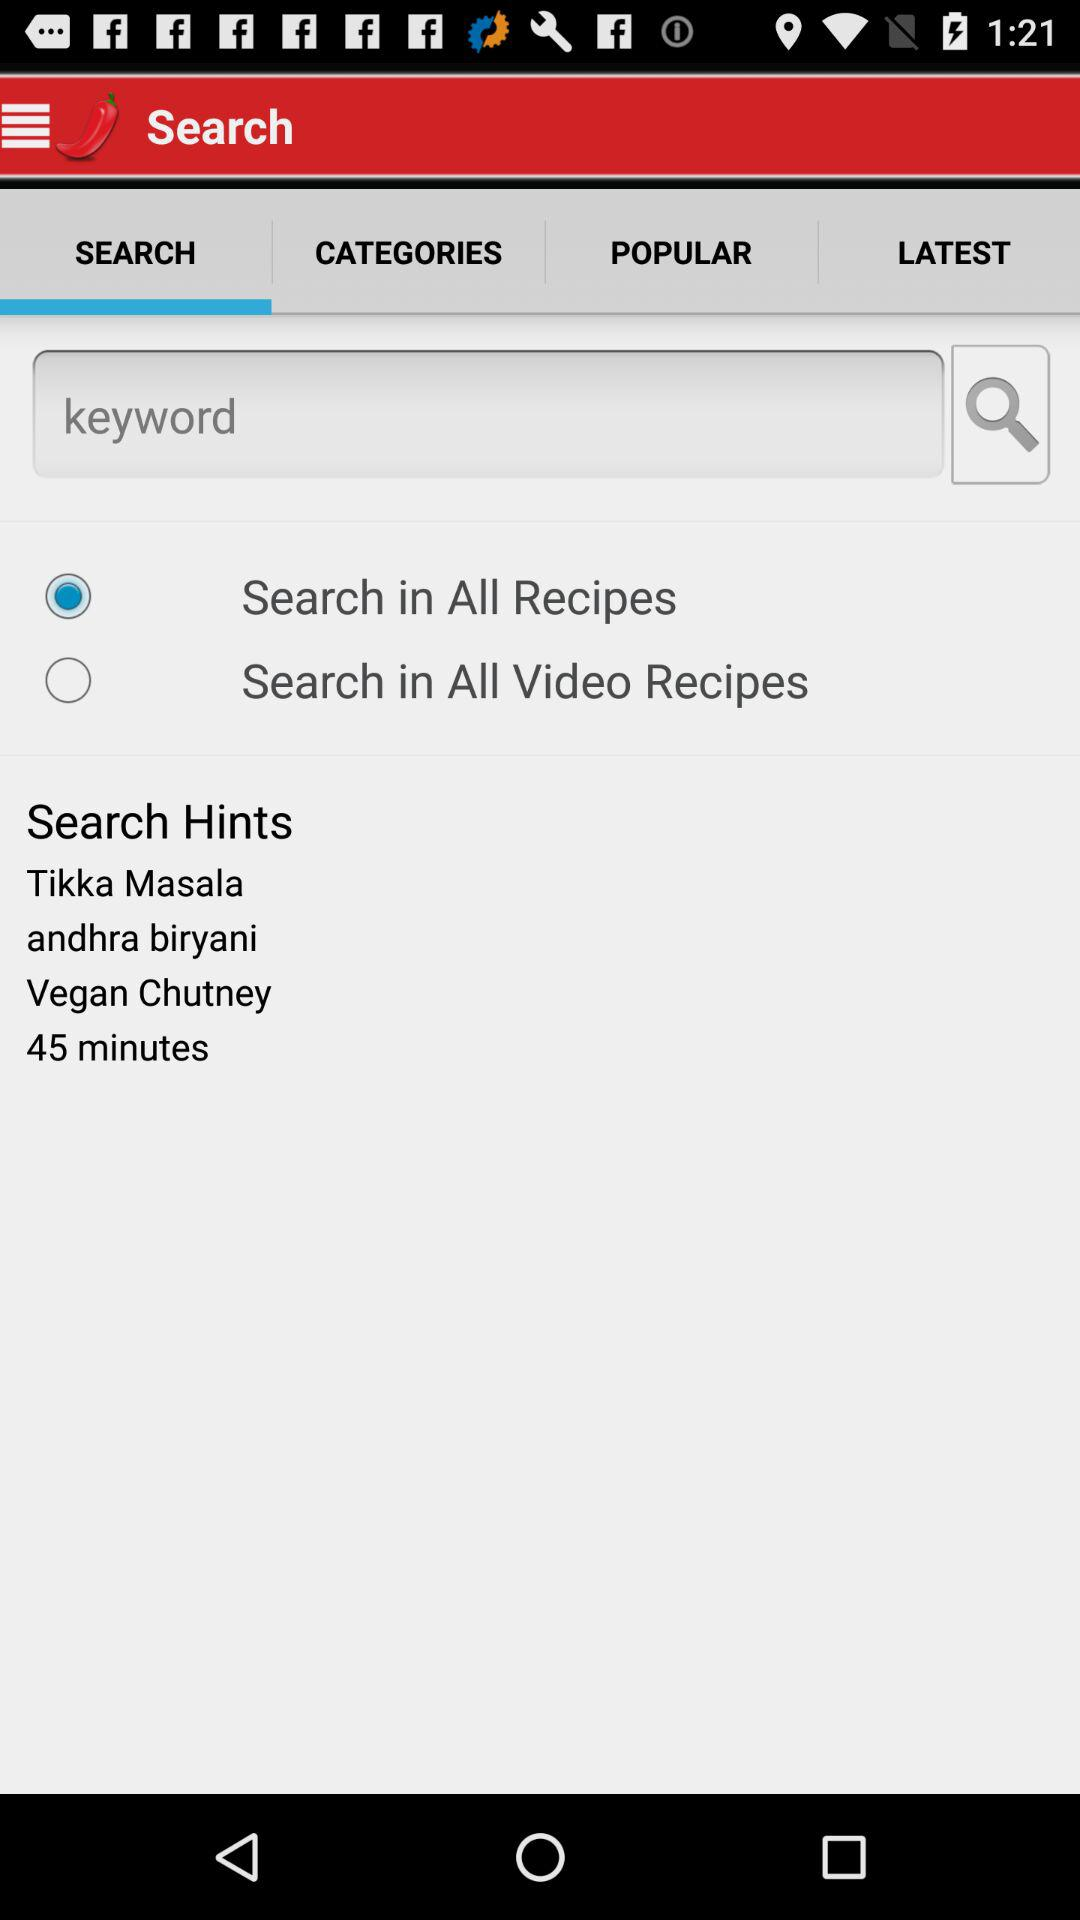What are the dishes' names in the search hints? The dishes' names are "Tikka Masala", "andhra biryani" and "Vegan Chutney". 